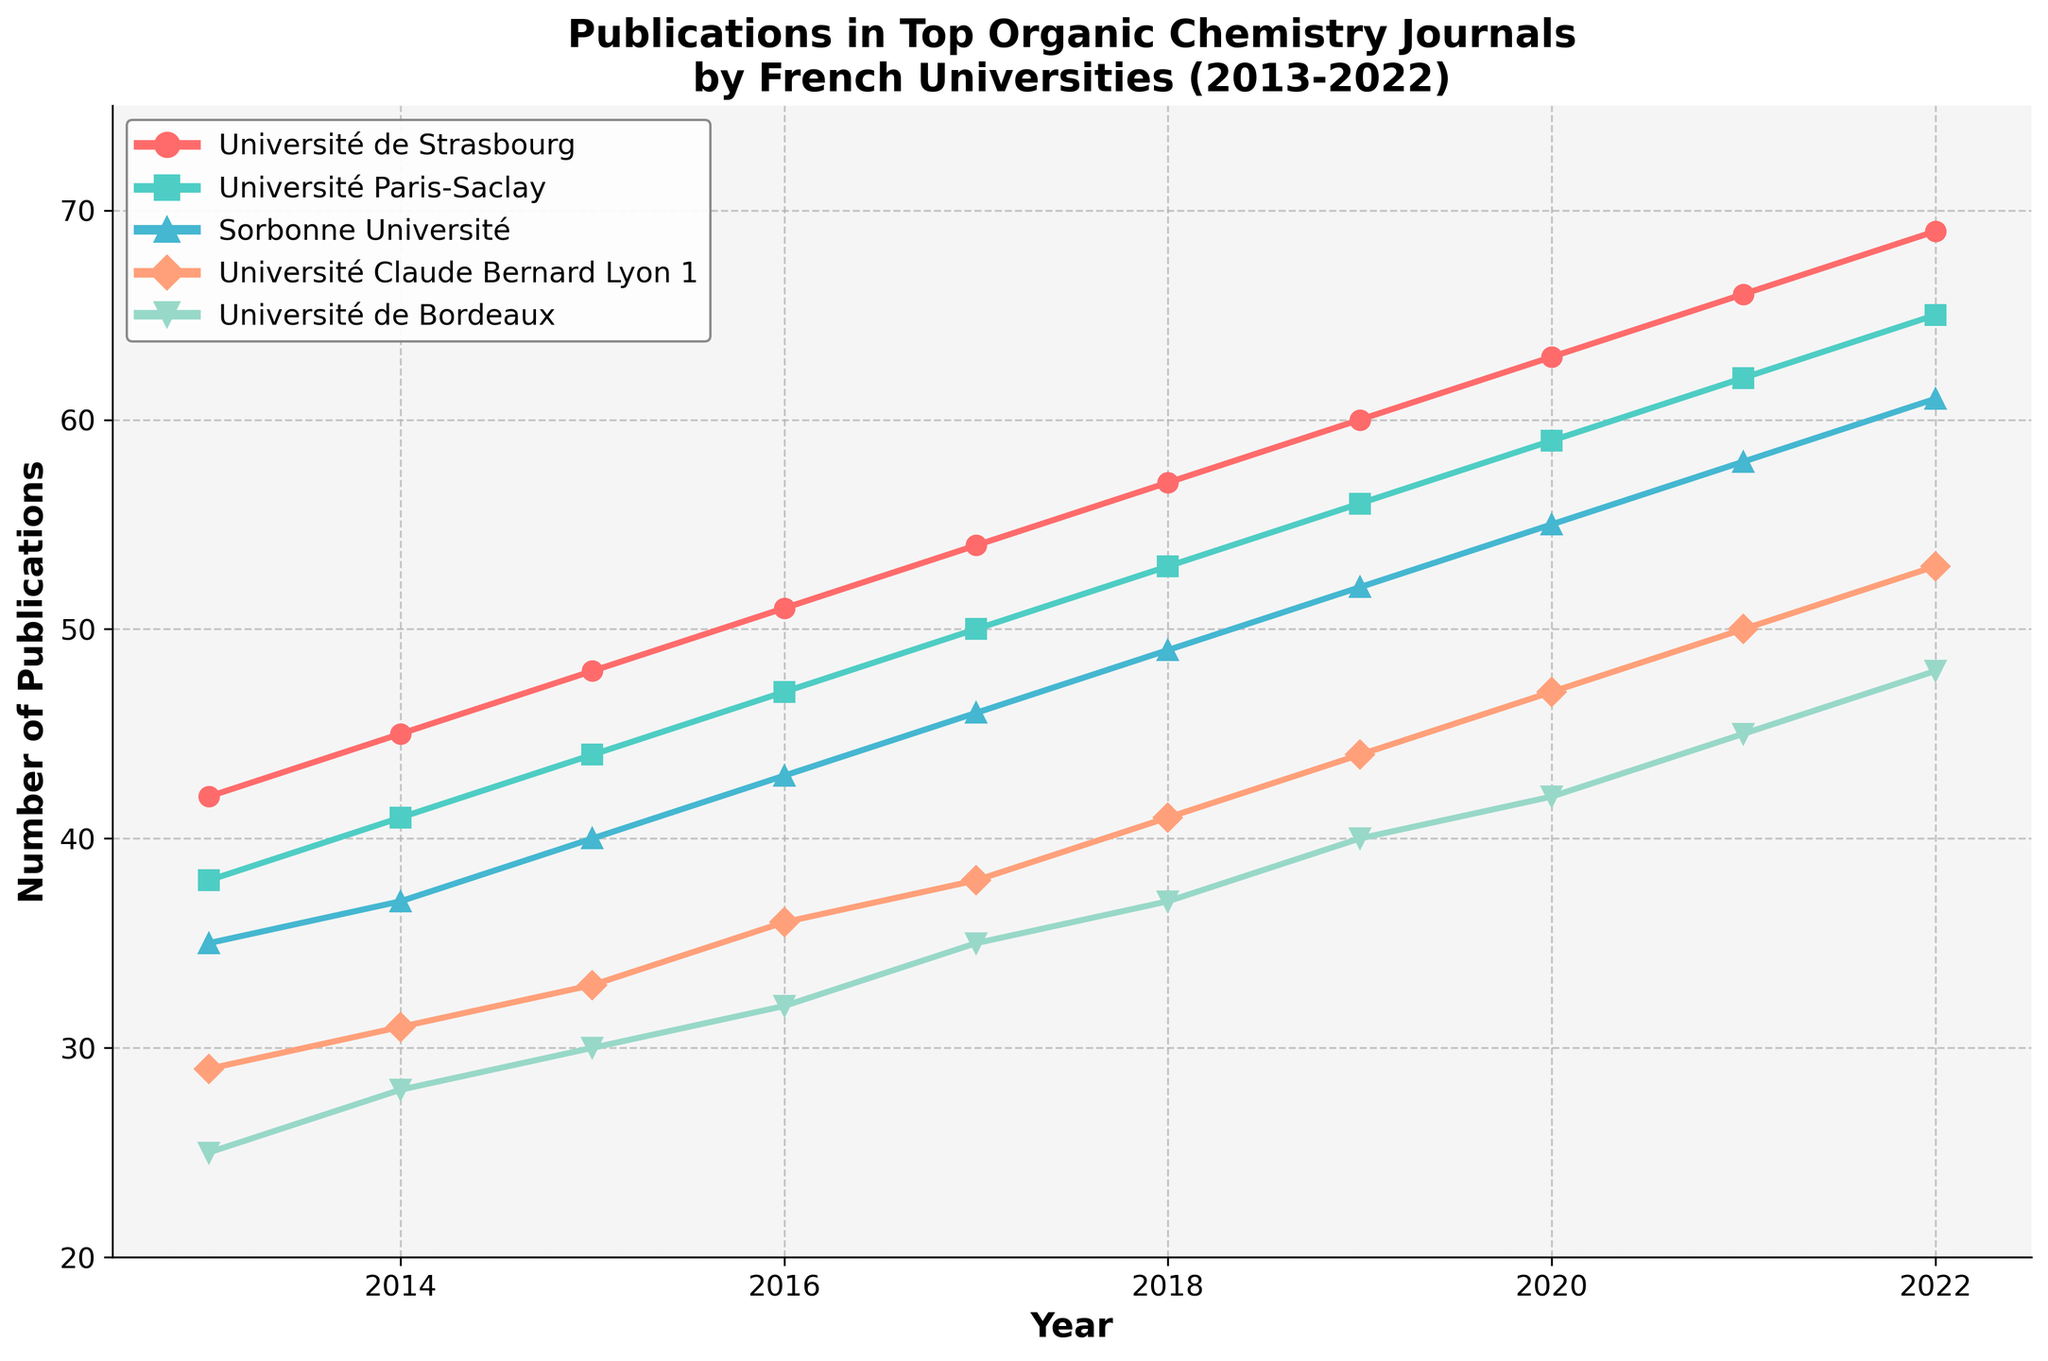Which university had the highest number of publications in 2022? To determine this, look for the university with the highest y-value at the year 2022 on the plot. Université de Strasbourg shows the highest number of publications in 2022.
Answer: Université de Strasbourg What was the increase in the number of publications for Sorbonne Université from 2013 to 2022? Identify the y-values for Sorbonne Université for the years 2013 and 2022, then subtract the 2013 value from the 2022 value (61 - 35).
Answer: 26 Which university showed the most consistent linear growth in publications over the decade? Observe the slopes of the lines; the one with the most consistent slope indicates linear growth. Université de Strasbourg shows consistent linear growth.
Answer: Université de Strasbourg How many more publications did Université Paris-Saclay have in 2020 compared to Université de Bordeaux? Identify the y-values of both universities for the year 2020 (59 for Université Paris-Saclay and 42 for Université de Bordeaux), then subtract the value for Université de Bordeaux from that for Université Paris-Saclay (59 - 42).
Answer: 17 Which university had the steepest increase in publications in any single year? Look at the plot and establish which line segment between two consecutive years has the steepest positive slope. The segment with the steepest slope is for Université de Strasbourg around 2021.
Answer: Université de Strasbourg What was the average number of publications for Université Claude Bernard Lyon 1 over the decade? Sum the number of publications for Université Claude Bernard Lyon 1 from 2013 to 2022 and divide by the number of years (10). The sum is 34+36+38+41+44+47+50+53 = 416, and the average is 416/10.
Answer: 38 Which year had the highest collective number of publications from all universities? Sum the number of publications of all universities for each year and identify the year with the highest sum. The year with the highest collective number (69+65+61+53+48 = 60) is 2022.
Answer: 2022 Did any university have a year where their number of publications decreased compared to the previous year? Observe all the lines. Since all lines are increasing year over year, no university had such a year.
Answer: No Which two universities had the closest number of publications in any given year? Look for lines that converge or are very close in y-values in any one year. The closest publications were from Université Claude Bernard Lyon 1 and Université de Bordeaux in 2017.
Answer: Université Claude Bernard Lyon 1 and Université de Bordeaux 